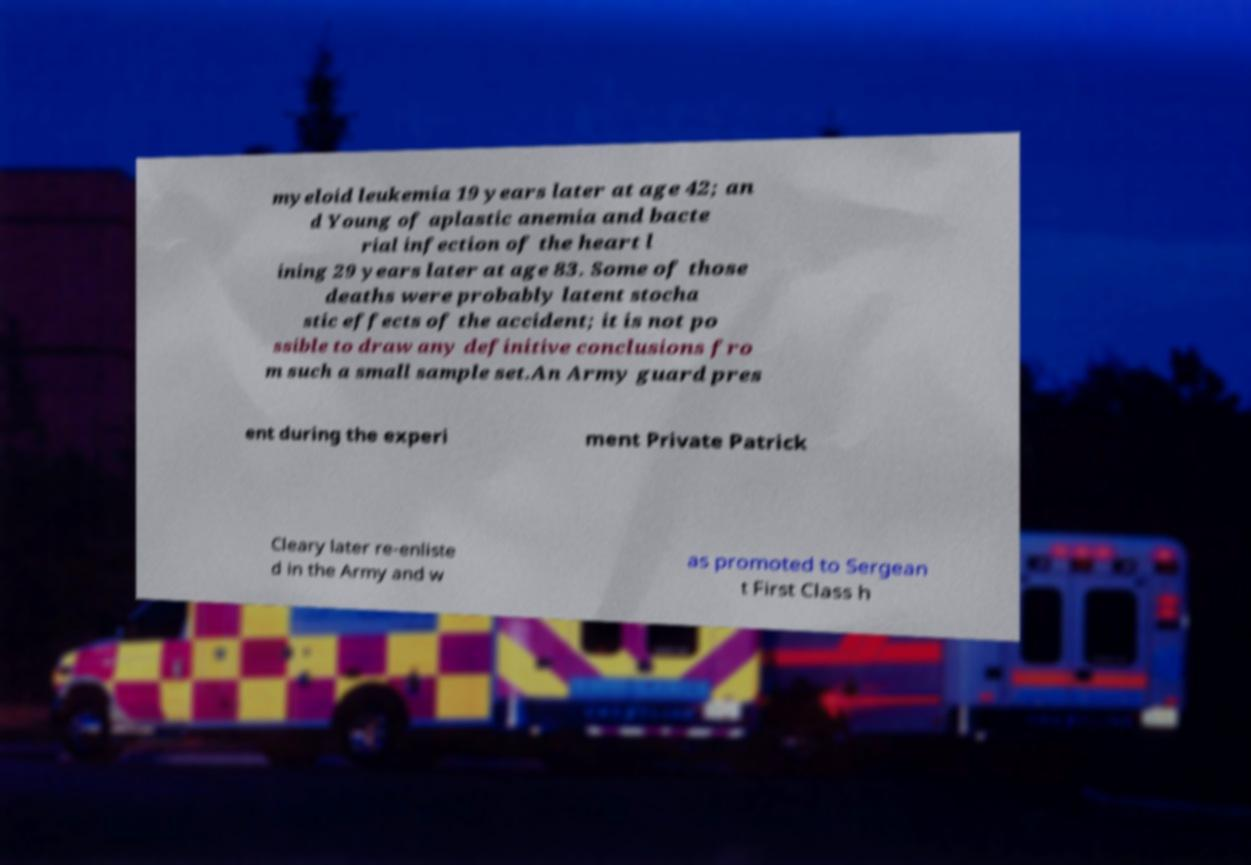I need the written content from this picture converted into text. Can you do that? myeloid leukemia 19 years later at age 42; an d Young of aplastic anemia and bacte rial infection of the heart l ining 29 years later at age 83. Some of those deaths were probably latent stocha stic effects of the accident; it is not po ssible to draw any definitive conclusions fro m such a small sample set.An Army guard pres ent during the experi ment Private Patrick Cleary later re-enliste d in the Army and w as promoted to Sergean t First Class h 